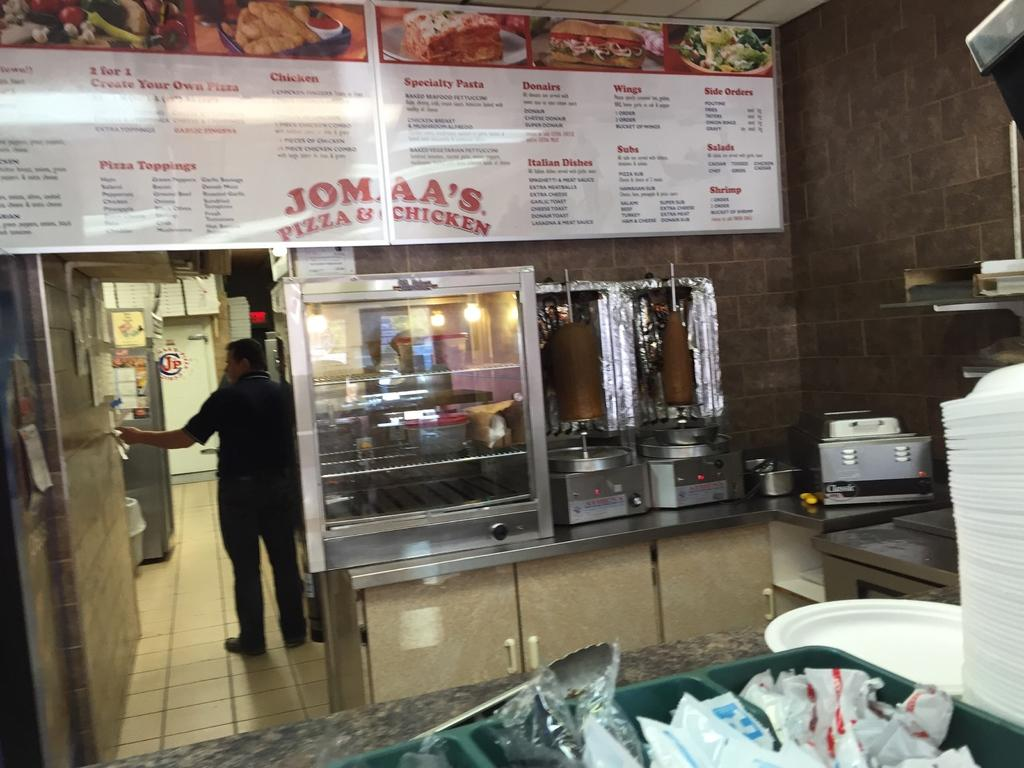<image>
Create a compact narrative representing the image presented. Man working in a restaurant named Jomaa's Pizza & Chicken. 